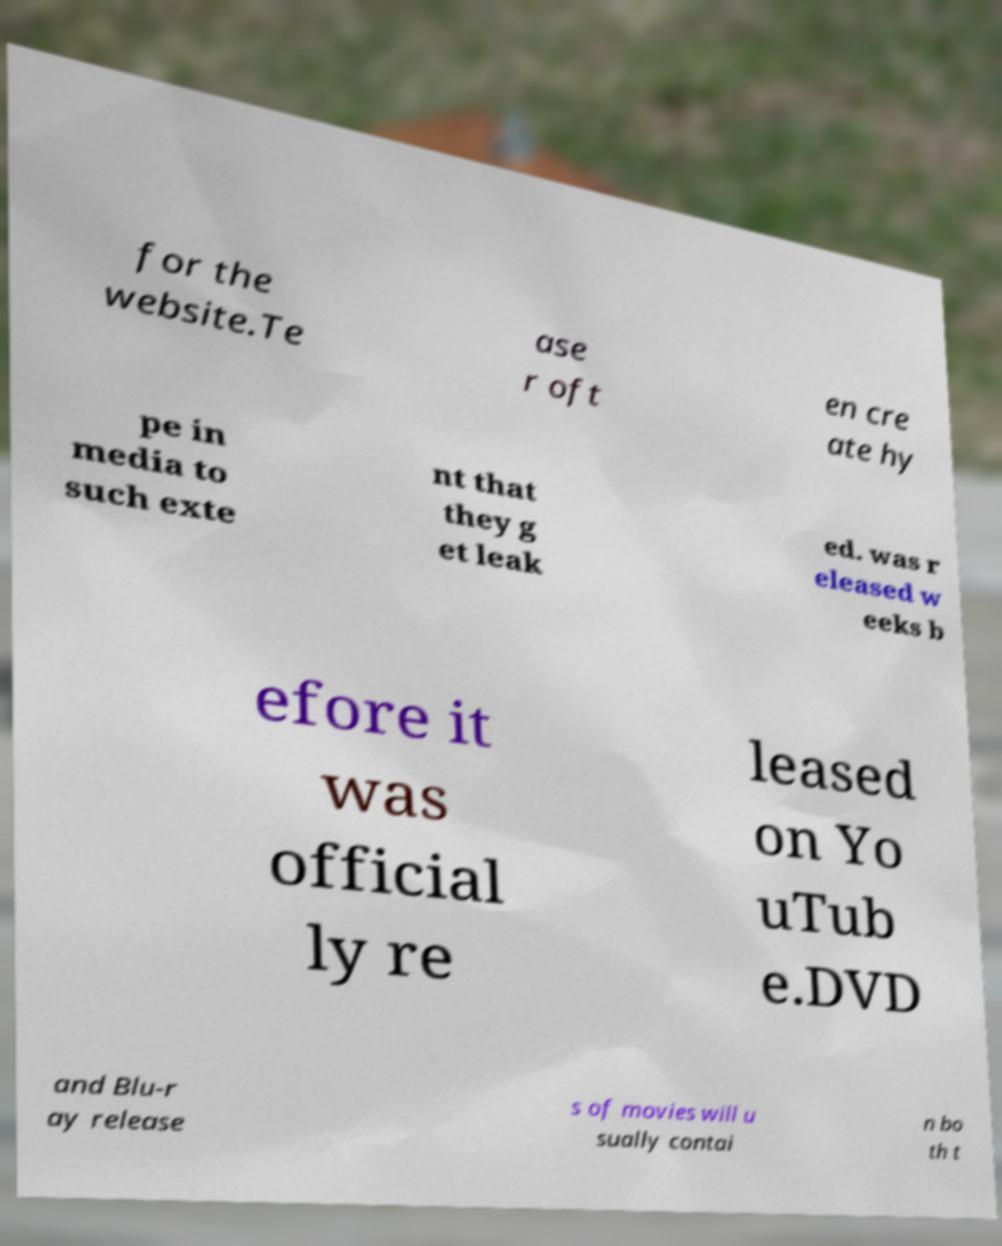What messages or text are displayed in this image? I need them in a readable, typed format. for the website.Te ase r oft en cre ate hy pe in media to such exte nt that they g et leak ed. was r eleased w eeks b efore it was official ly re leased on Yo uTub e.DVD and Blu-r ay release s of movies will u sually contai n bo th t 